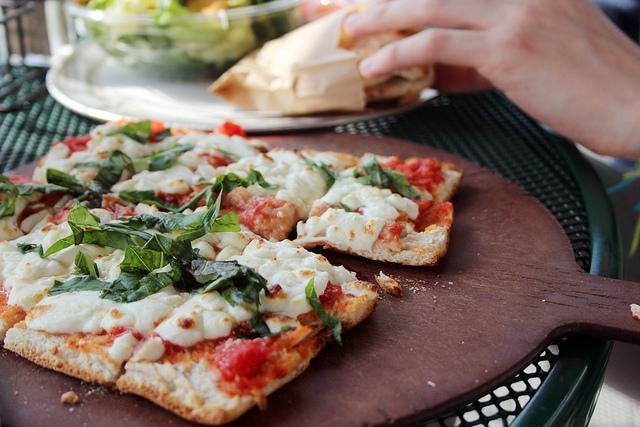Why is the pizza cut into small pieces? Please explain your reasoning. easier eating. This serving style is consistent with the food present. because of the thinness of the crust it is likely large slices would bend and be difficult to insert into one's mouth. 